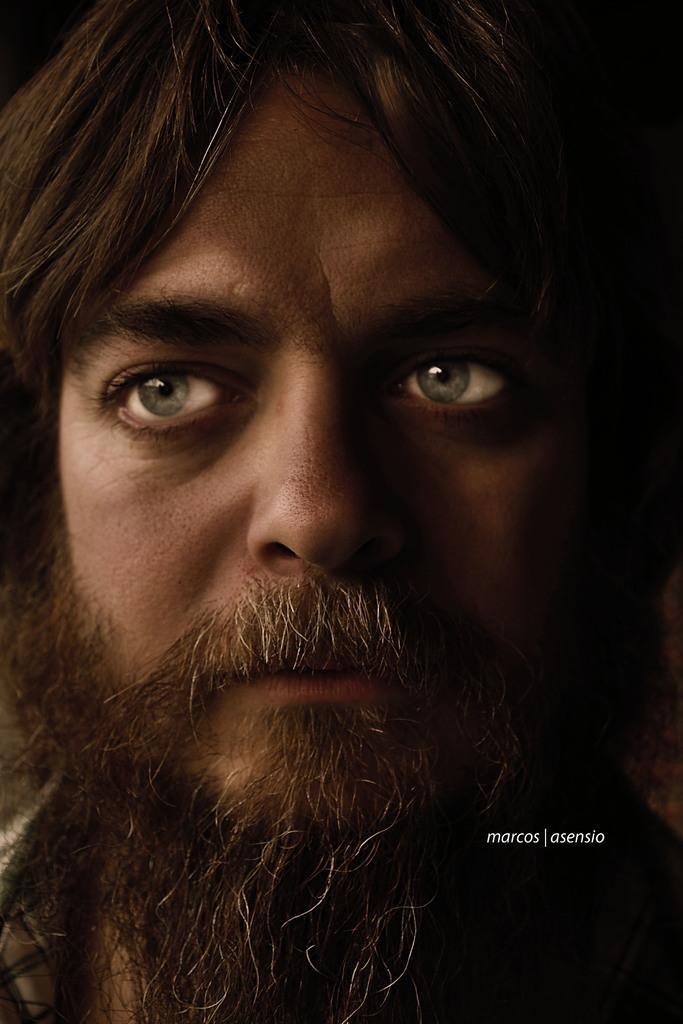Please provide a concise description of this image. A picture of a person face. He is looking left side of the image. Right side of the image there is a watermark. 